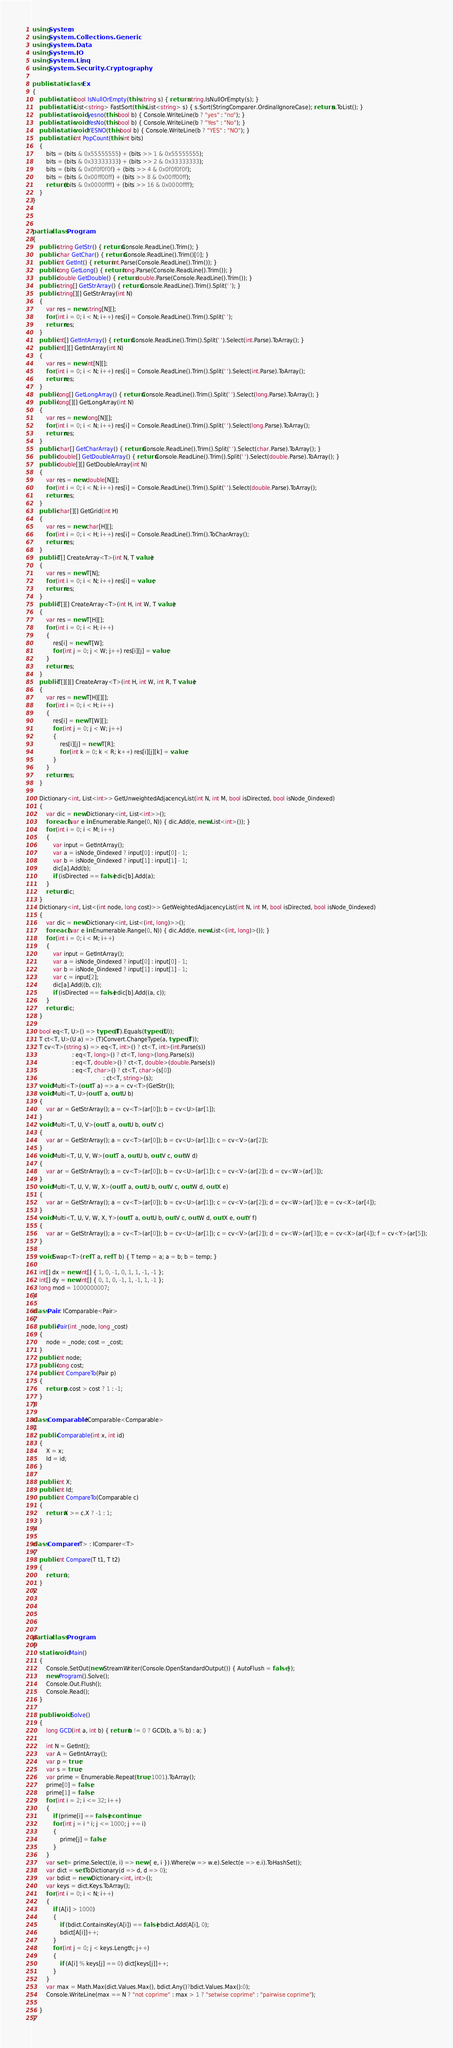<code> <loc_0><loc_0><loc_500><loc_500><_C#_>using System;
using System.Collections.Generic;
using System.Data;
using System.IO;
using System.Linq;
using System.Security.Cryptography;

public static class Ex
{
    public static bool IsNullOrEmpty(this string s) { return string.IsNullOrEmpty(s); }
    public static List<string> FastSort(this List<string> s) { s.Sort(StringComparer.OrdinalIgnoreCase); return s.ToList(); }
    public static void yesno(this bool b) { Console.WriteLine(b ? "yes" : "no"); }
    public static void YesNo(this bool b) { Console.WriteLine(b ? "Yes" : "No"); }
    public static void YESNO(this bool b) { Console.WriteLine(b ? "YES" : "NO"); }
    public static int PopCount(this int bits)
    {
        bits = (bits & 0x55555555) + (bits >> 1 & 0x55555555);
        bits = (bits & 0x33333333) + (bits >> 2 & 0x33333333);
        bits = (bits & 0x0f0f0f0f) + (bits >> 4 & 0x0f0f0f0f);
        bits = (bits & 0x00ff00ff) + (bits >> 8 & 0x00ff00ff);
        return (bits & 0x0000ffff) + (bits >> 16 & 0x0000ffff);
    }
}



partial class Program
{
    public string GetStr() { return Console.ReadLine().Trim(); }
    public char GetChar() { return Console.ReadLine().Trim()[0]; }
    public int GetInt() { return int.Parse(Console.ReadLine().Trim()); }
    public long GetLong() { return long.Parse(Console.ReadLine().Trim()); }
    public double GetDouble() { return double.Parse(Console.ReadLine().Trim()); }
    public string[] GetStrArray() { return Console.ReadLine().Trim().Split(' '); }
    public string[][] GetStrArray(int N)
    {
        var res = new string[N][];
        for (int i = 0; i < N; i++) res[i] = Console.ReadLine().Trim().Split(' ');
        return res;
    }
    public int[] GetIntArray() { return Console.ReadLine().Trim().Split(' ').Select(int.Parse).ToArray(); }
    public int[][] GetIntArray(int N)
    {
        var res = new int[N][];
        for (int i = 0; i < N; i++) res[i] = Console.ReadLine().Trim().Split(' ').Select(int.Parse).ToArray();
        return res;
    }
    public long[] GetLongArray() { return Console.ReadLine().Trim().Split(' ').Select(long.Parse).ToArray(); }
    public long[][] GetLongArray(int N)
    {
        var res = new long[N][];
        for (int i = 0; i < N; i++) res[i] = Console.ReadLine().Trim().Split(' ').Select(long.Parse).ToArray();
        return res;
    }
    public char[] GetCharArray() { return Console.ReadLine().Trim().Split(' ').Select(char.Parse).ToArray(); }
    public double[] GetDoubleArray() { return Console.ReadLine().Trim().Split(' ').Select(double.Parse).ToArray(); }
    public double[][] GetDoubleArray(int N)
    {
        var res = new double[N][];
        for (int i = 0; i < N; i++) res[i] = Console.ReadLine().Trim().Split(' ').Select(double.Parse).ToArray();
        return res;
    }
    public char[][] GetGrid(int H)
    {
        var res = new char[H][];
        for (int i = 0; i < H; i++) res[i] = Console.ReadLine().Trim().ToCharArray();
        return res;
    }
    public T[] CreateArray<T>(int N, T value)
    {
        var res = new T[N];
        for (int i = 0; i < N; i++) res[i] = value;
        return res;
    }
    public T[][] CreateArray<T>(int H, int W, T value)
    {
        var res = new T[H][];
        for (int i = 0; i < H; i++)
        {
            res[i] = new T[W];
            for (int j = 0; j < W; j++) res[i][j] = value;
        }
        return res;
    }
    public T[][][] CreateArray<T>(int H, int W, int R, T value)
    {
        var res = new T[H][][];
        for (int i = 0; i < H; i++)
        {
            res[i] = new T[W][];
            for (int j = 0; j < W; j++)
            {
                res[i][j] = new T[R];
                for (int k = 0; k < R; k++) res[i][j][k] = value;
            }
        }
        return res;
    }

    Dictionary<int, List<int>> GetUnweightedAdjacencyList(int N, int M, bool isDirected, bool isNode_0indexed)
    {
        var dic = new Dictionary<int, List<int>>();
        foreach (var e in Enumerable.Range(0, N)) { dic.Add(e, new List<int>()); }
        for (int i = 0; i < M; i++)
        {
            var input = GetIntArray();
            var a = isNode_0indexed ? input[0] : input[0] - 1;
            var b = isNode_0indexed ? input[1] : input[1] - 1;
            dic[a].Add(b);
            if (isDirected == false) dic[b].Add(a);
        }
        return dic;
    }
    Dictionary<int, List<(int node, long cost)>> GetWeightedAdjacencyList(int N, int M, bool isDirected, bool isNode_0indexed)
    {
        var dic = new Dictionary<int, List<(int, long)>>();
        foreach (var e in Enumerable.Range(0, N)) { dic.Add(e, new List<(int, long)>()); }
        for (int i = 0; i < M; i++)
        {
            var input = GetIntArray();
            var a = isNode_0indexed ? input[0] : input[0] - 1;
            var b = isNode_0indexed ? input[1] : input[1] - 1;
            var c = input[2];
            dic[a].Add((b, c));
            if (isDirected == false) dic[b].Add((a, c));
        }
        return dic;
    }

    bool eq<T, U>() => typeof(T).Equals(typeof(U));
    T ct<T, U>(U a) => (T)Convert.ChangeType(a, typeof(T));
    T cv<T>(string s) => eq<T, int>() ? ct<T, int>(int.Parse(s))
                       : eq<T, long>() ? ct<T, long>(long.Parse(s))
                       : eq<T, double>() ? ct<T, double>(double.Parse(s))
                       : eq<T, char>() ? ct<T, char>(s[0])
                                         : ct<T, string>(s);
    void Multi<T>(out T a) => a = cv<T>(GetStr());
    void Multi<T, U>(out T a, out U b)
    {
        var ar = GetStrArray(); a = cv<T>(ar[0]); b = cv<U>(ar[1]);
    }
    void Multi<T, U, V>(out T a, out U b, out V c)
    {
        var ar = GetStrArray(); a = cv<T>(ar[0]); b = cv<U>(ar[1]); c = cv<V>(ar[2]);
    }
    void Multi<T, U, V, W>(out T a, out U b, out V c, out W d)
    {
        var ar = GetStrArray(); a = cv<T>(ar[0]); b = cv<U>(ar[1]); c = cv<V>(ar[2]); d = cv<W>(ar[3]);
    }
    void Multi<T, U, V, W, X>(out T a, out U b, out V c, out W d, out X e)
    {
        var ar = GetStrArray(); a = cv<T>(ar[0]); b = cv<U>(ar[1]); c = cv<V>(ar[2]); d = cv<W>(ar[3]); e = cv<X>(ar[4]);
    }
    void Multi<T, U, V, W, X, Y>(out T a, out U b, out V c, out W d, out X e, out Y f)
    {
        var ar = GetStrArray(); a = cv<T>(ar[0]); b = cv<U>(ar[1]); c = cv<V>(ar[2]); d = cv<W>(ar[3]); e = cv<X>(ar[4]); f = cv<Y>(ar[5]);
    }

    void Swap<T>(ref T a, ref T b) { T temp = a; a = b; b = temp; }

    int[] dx = new int[] { 1, 0, -1, 0, 1, 1, -1, -1 };
    int[] dy = new int[] { 0, 1, 0, -1, 1, -1, 1, -1 };
    long mod = 1000000007;
}

class Pair : IComparable<Pair>
{
    public Pair(int _node, long _cost)
    {
        node = _node; cost = _cost;
    }
    public int node;
    public long cost;
    public int CompareTo(Pair p)
    {
        return p.cost > cost ? 1 : -1;
    }
}

class Comparable : IComparable<Comparable>
{
    public Comparable(int x, int id)
    {
        X = x;
        Id = id;
    }

    public int X;
    public int Id;
    public int CompareTo(Comparable c)
    {
        return X >= c.X ? -1 : 1;
    }
}

class Comparer<T> : IComparer<T>
{
    public int Compare(T t1, T t2)
    {
        return 1;
    }
}





partial class Program
{
    static void Main()
    {
        Console.SetOut(new StreamWriter(Console.OpenStandardOutput()) { AutoFlush = false });
        new Program().Solve();
        Console.Out.Flush();
        Console.Read();
    }

    public void Solve()
    {
        long GCD(int a, int b) { return b != 0 ? GCD(b, a % b) : a; }

        int N = GetInt();
        var A = GetIntArray();
        var p = true;
        var s = true;
        var prime = Enumerable.Repeat(true, 1001).ToArray();
        prime[0] = false;
        prime[1] = false;
        for (int i = 2; i <= 32; i++)
        {
            if (prime[i] == false) continue;
            for (int j = i * i; j <= 1000; j += i)
            {
                prime[j] = false;
            }
        }
        var set = prime.Select((e, i) => new { e, i }).Where(w => w.e).Select(e => e.i).ToHashSet();
        var dict = set.ToDictionary(d => d, d => 0);
        var bdict = new Dictionary<int, int>();
        var keys = dict.Keys.ToArray();
        for (int i = 0; i < N; i++)
        {
            if (A[i] > 1000)
            {
                if (bdict.ContainsKey(A[i]) == false) bdict.Add(A[i], 0);
                bdict[A[i]]++;
            }
            for (int j = 0; j < keys.Length; j++)
            {
                if (A[i] % keys[j] == 0) dict[keys[j]]++;
            }
        }
        var max = Math.Max(dict.Values.Max(), bdict.Any()?bdict.Values.Max():0);
        Console.WriteLine(max == N ? "not coprime" : max > 1 ? "setwise coprime" : "pairwise coprime");

    }
}</code> 